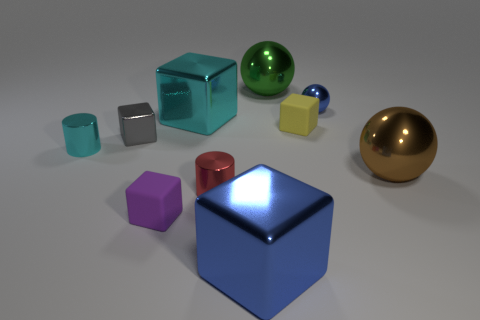What number of purple objects are metal objects or tiny metallic cylinders?
Offer a terse response. 0. Are there fewer large brown metallic things behind the gray metallic cube than tiny cyan things?
Ensure brevity in your answer.  Yes. There is a big shiny ball that is right of the blue shiny ball; how many brown objects are behind it?
Your answer should be very brief. 0. What number of other objects are the same size as the purple matte cube?
Make the answer very short. 5. What number of things are large brown matte cubes or tiny cylinders right of the purple block?
Your answer should be compact. 1. Are there fewer purple rubber objects than tiny things?
Provide a succinct answer. Yes. There is a small rubber object behind the rubber thing left of the green sphere; what color is it?
Make the answer very short. Yellow. There is a brown thing that is the same shape as the green metallic object; what material is it?
Your response must be concise. Metal. How many shiny objects are either small blue balls or large blue blocks?
Offer a terse response. 2. Do the big ball in front of the green thing and the cube that is to the right of the large blue metallic cube have the same material?
Your answer should be very brief. No. 